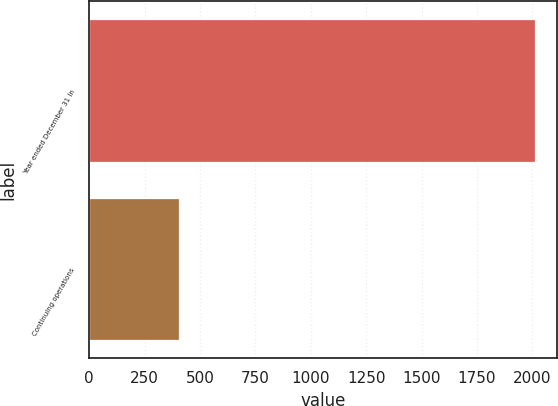Convert chart to OTSL. <chart><loc_0><loc_0><loc_500><loc_500><bar_chart><fcel>Year ended December 31 In<fcel>Continuing operations<nl><fcel>2012<fcel>405<nl></chart> 